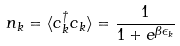<formula> <loc_0><loc_0><loc_500><loc_500>n _ { k } = \langle c _ { k } ^ { \dagger } c _ { k } \rangle = \frac { 1 } { 1 + e ^ { \beta \epsilon _ { k } } }</formula> 